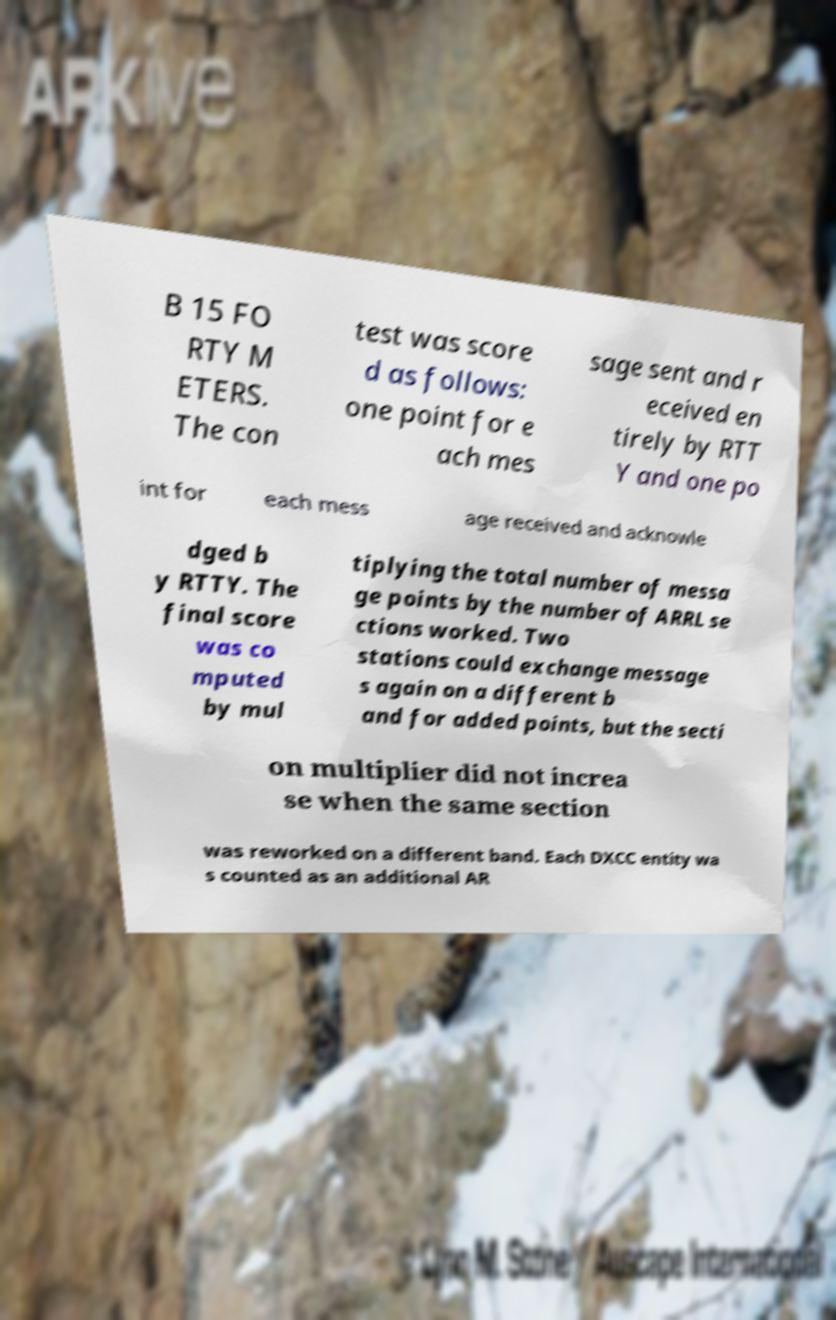Could you extract and type out the text from this image? B 15 FO RTY M ETERS. The con test was score d as follows: one point for e ach mes sage sent and r eceived en tirely by RTT Y and one po int for each mess age received and acknowle dged b y RTTY. The final score was co mputed by mul tiplying the total number of messa ge points by the number of ARRL se ctions worked. Two stations could exchange message s again on a different b and for added points, but the secti on multiplier did not increa se when the same section was reworked on a different band. Each DXCC entity wa s counted as an additional AR 